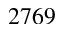<formula> <loc_0><loc_0><loc_500><loc_500>2 7 6 9</formula> 